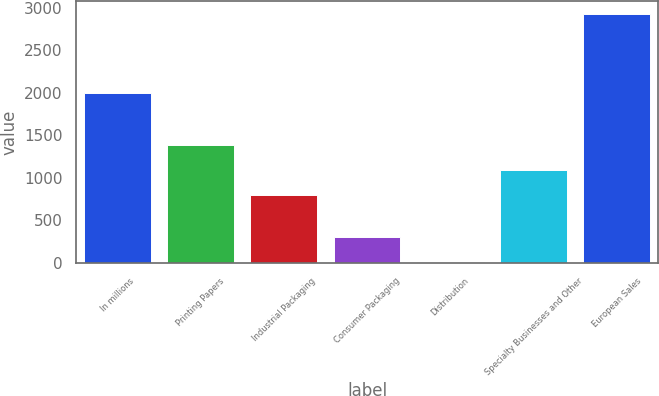Convert chart to OTSL. <chart><loc_0><loc_0><loc_500><loc_500><bar_chart><fcel>In millions<fcel>Printing Papers<fcel>Industrial Packaging<fcel>Consumer Packaging<fcel>Distribution<fcel>Specialty Businesses and Other<fcel>European Sales<nl><fcel>2003<fcel>1387.8<fcel>804<fcel>300.9<fcel>9<fcel>1095.9<fcel>2928<nl></chart> 